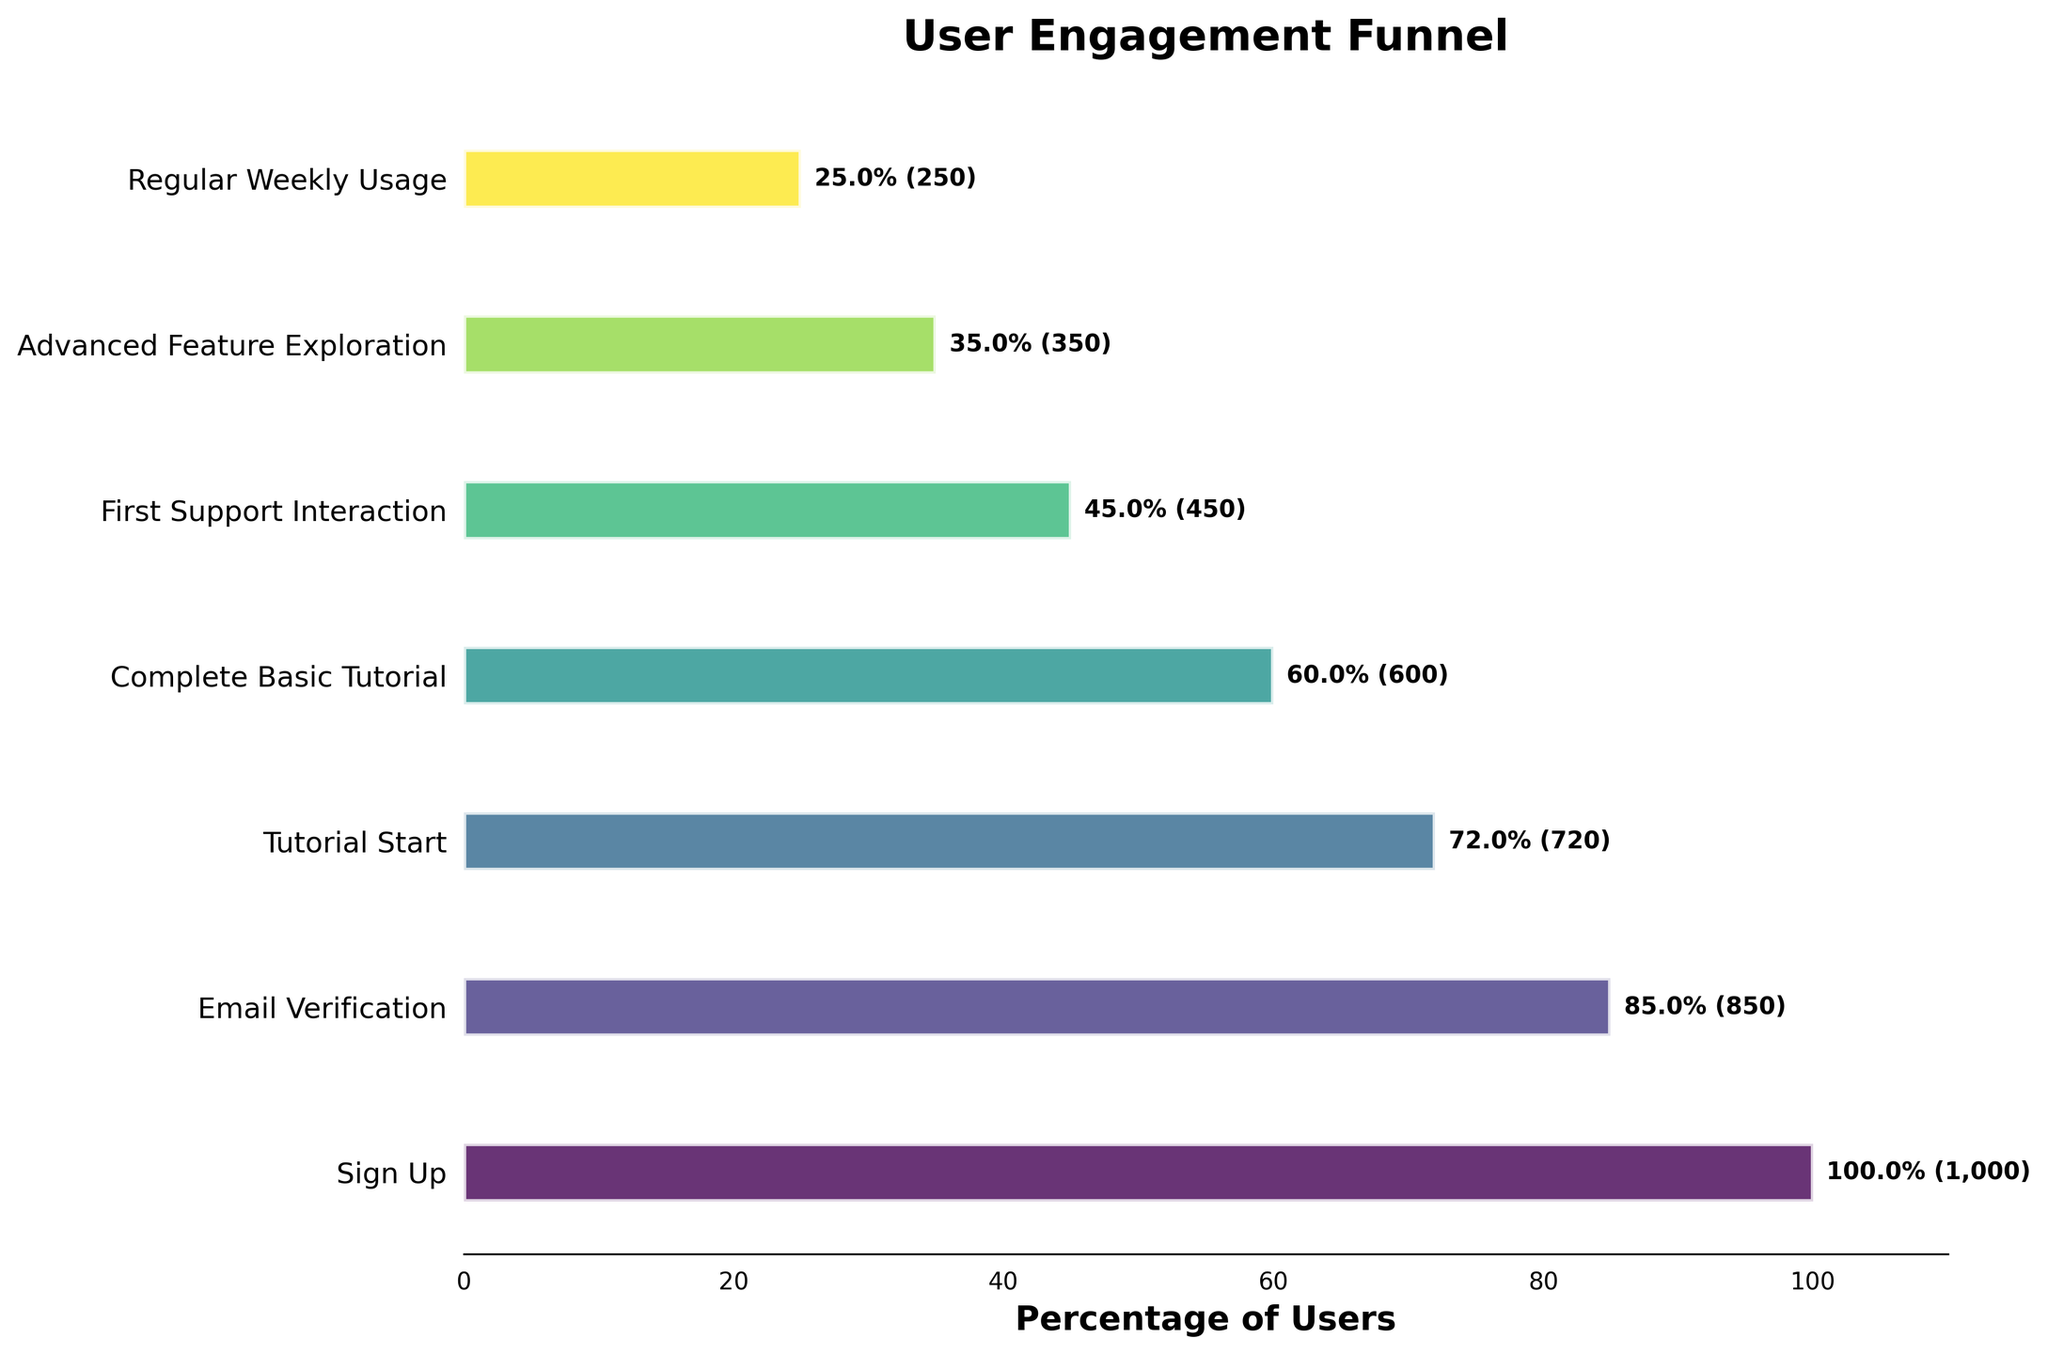What is the title of the plot? The title is at the top of the figure and summarizes the content of the plot. The title in the plot reads "User Engagement Funnel".
Answer: User Engagement Funnel How many stages are shown in the funnel chart? Count the number of unique stages along the y-axis. There are 7 stages displayed in the funnel chart.
Answer: 7 What percentage of users complete the "Email Verification" stage? Look at the bar corresponding to "Email Verification" and read the percentage label at the end of the bar. The label shows 85.0%, which means 85% of users complete this stage.
Answer: 85.0% Which stage has the largest drop-off in user count? Compare the differences in user counts between consecutive stages. The largest drop-off is between "Complete Basic Tutorial" (600 users) and "First Support Interaction" (450 users), resulting in a drop-off of 150 users.
Answer: Complete Basic Tutorial to First Support Interaction What is the user count at the "Regular Weekly Usage" stage? Identify the bar corresponding to "Regular Weekly Usage" and read the user count label next to the bar. It shows 250 users.
Answer: 250 How many users engage with "Advanced Feature Exploration"? Look at the bar and the label corresponding to "Advanced Feature Exploration". The label indicates that 350 users engage with this stage.
Answer: 350 What is the total drop-off percentage from "Sign Up" to "Regular Weekly Usage"? Calculate the percentage difference from the first stage to the last stage. Percentage drop-off = (100% - 25%) = 75%. This means there is a 75% drop-off in users from "Sign Up" to "Regular Weekly Usage".
Answer: 75% Which stage has the smallest percentage of users? The smallest percentage of users can be found by looking at the end of all the bars and identifying the smallest percentage. "Regular Weekly Usage" shows the smallest percentage, which is 25.0%.
Answer: Regular Weekly Usage How many users do not verify their email after sign up? Calculate the difference between the number of users in the "Sign Up" stage and the "Email Verification" stage. This is 1,000 (Sign Up) - 850 (Email Verification) = 150 users.
Answer: 150 What is the average percentage of users for all stages? Sum all the percentages and divide by the number of stages. Total percentage sum = 100% + 85% + 72% + 60% + 45% + 35% + 25% = 422%. Average = 422% / 7 stages = 60.3% (rounded to one decimal place).
Answer: 60.3% 